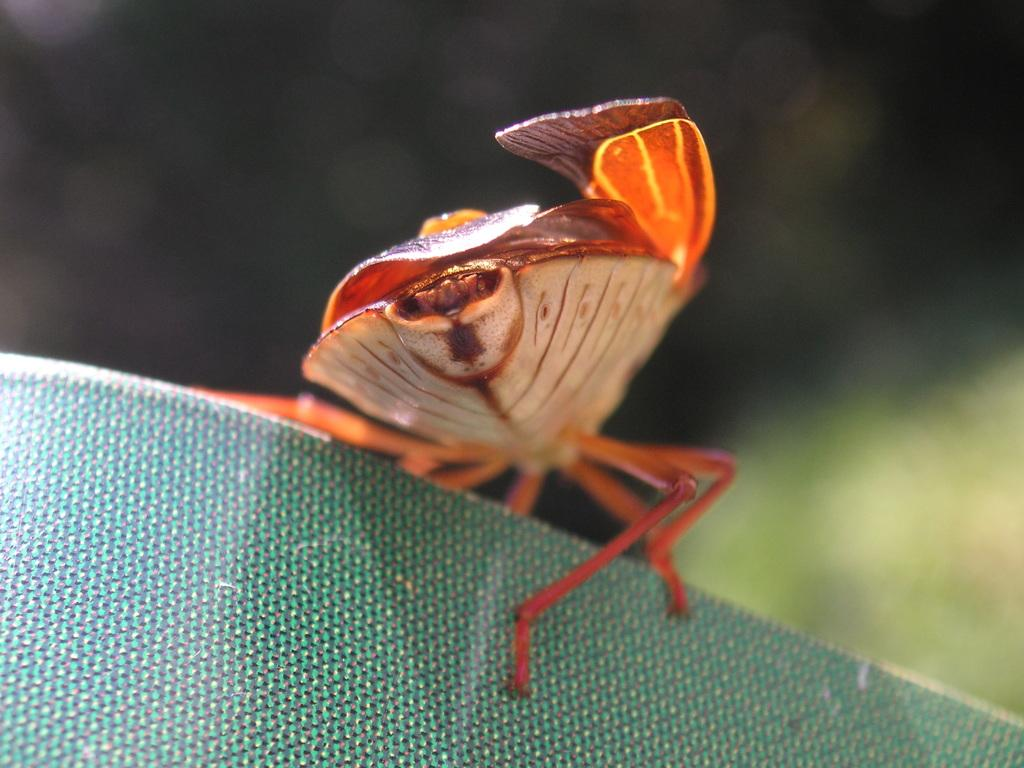What can be observed about the background of the image? The background of the image is blurred. What is the main subject of the image? There is an insect in the image. What is the color of the surface where the insect is located? The insect is on a green surface. What type of plants can be seen growing on the slope in the image? There is no slope or plants visible in the image; it features a blurred background and an insect on a green surface. 